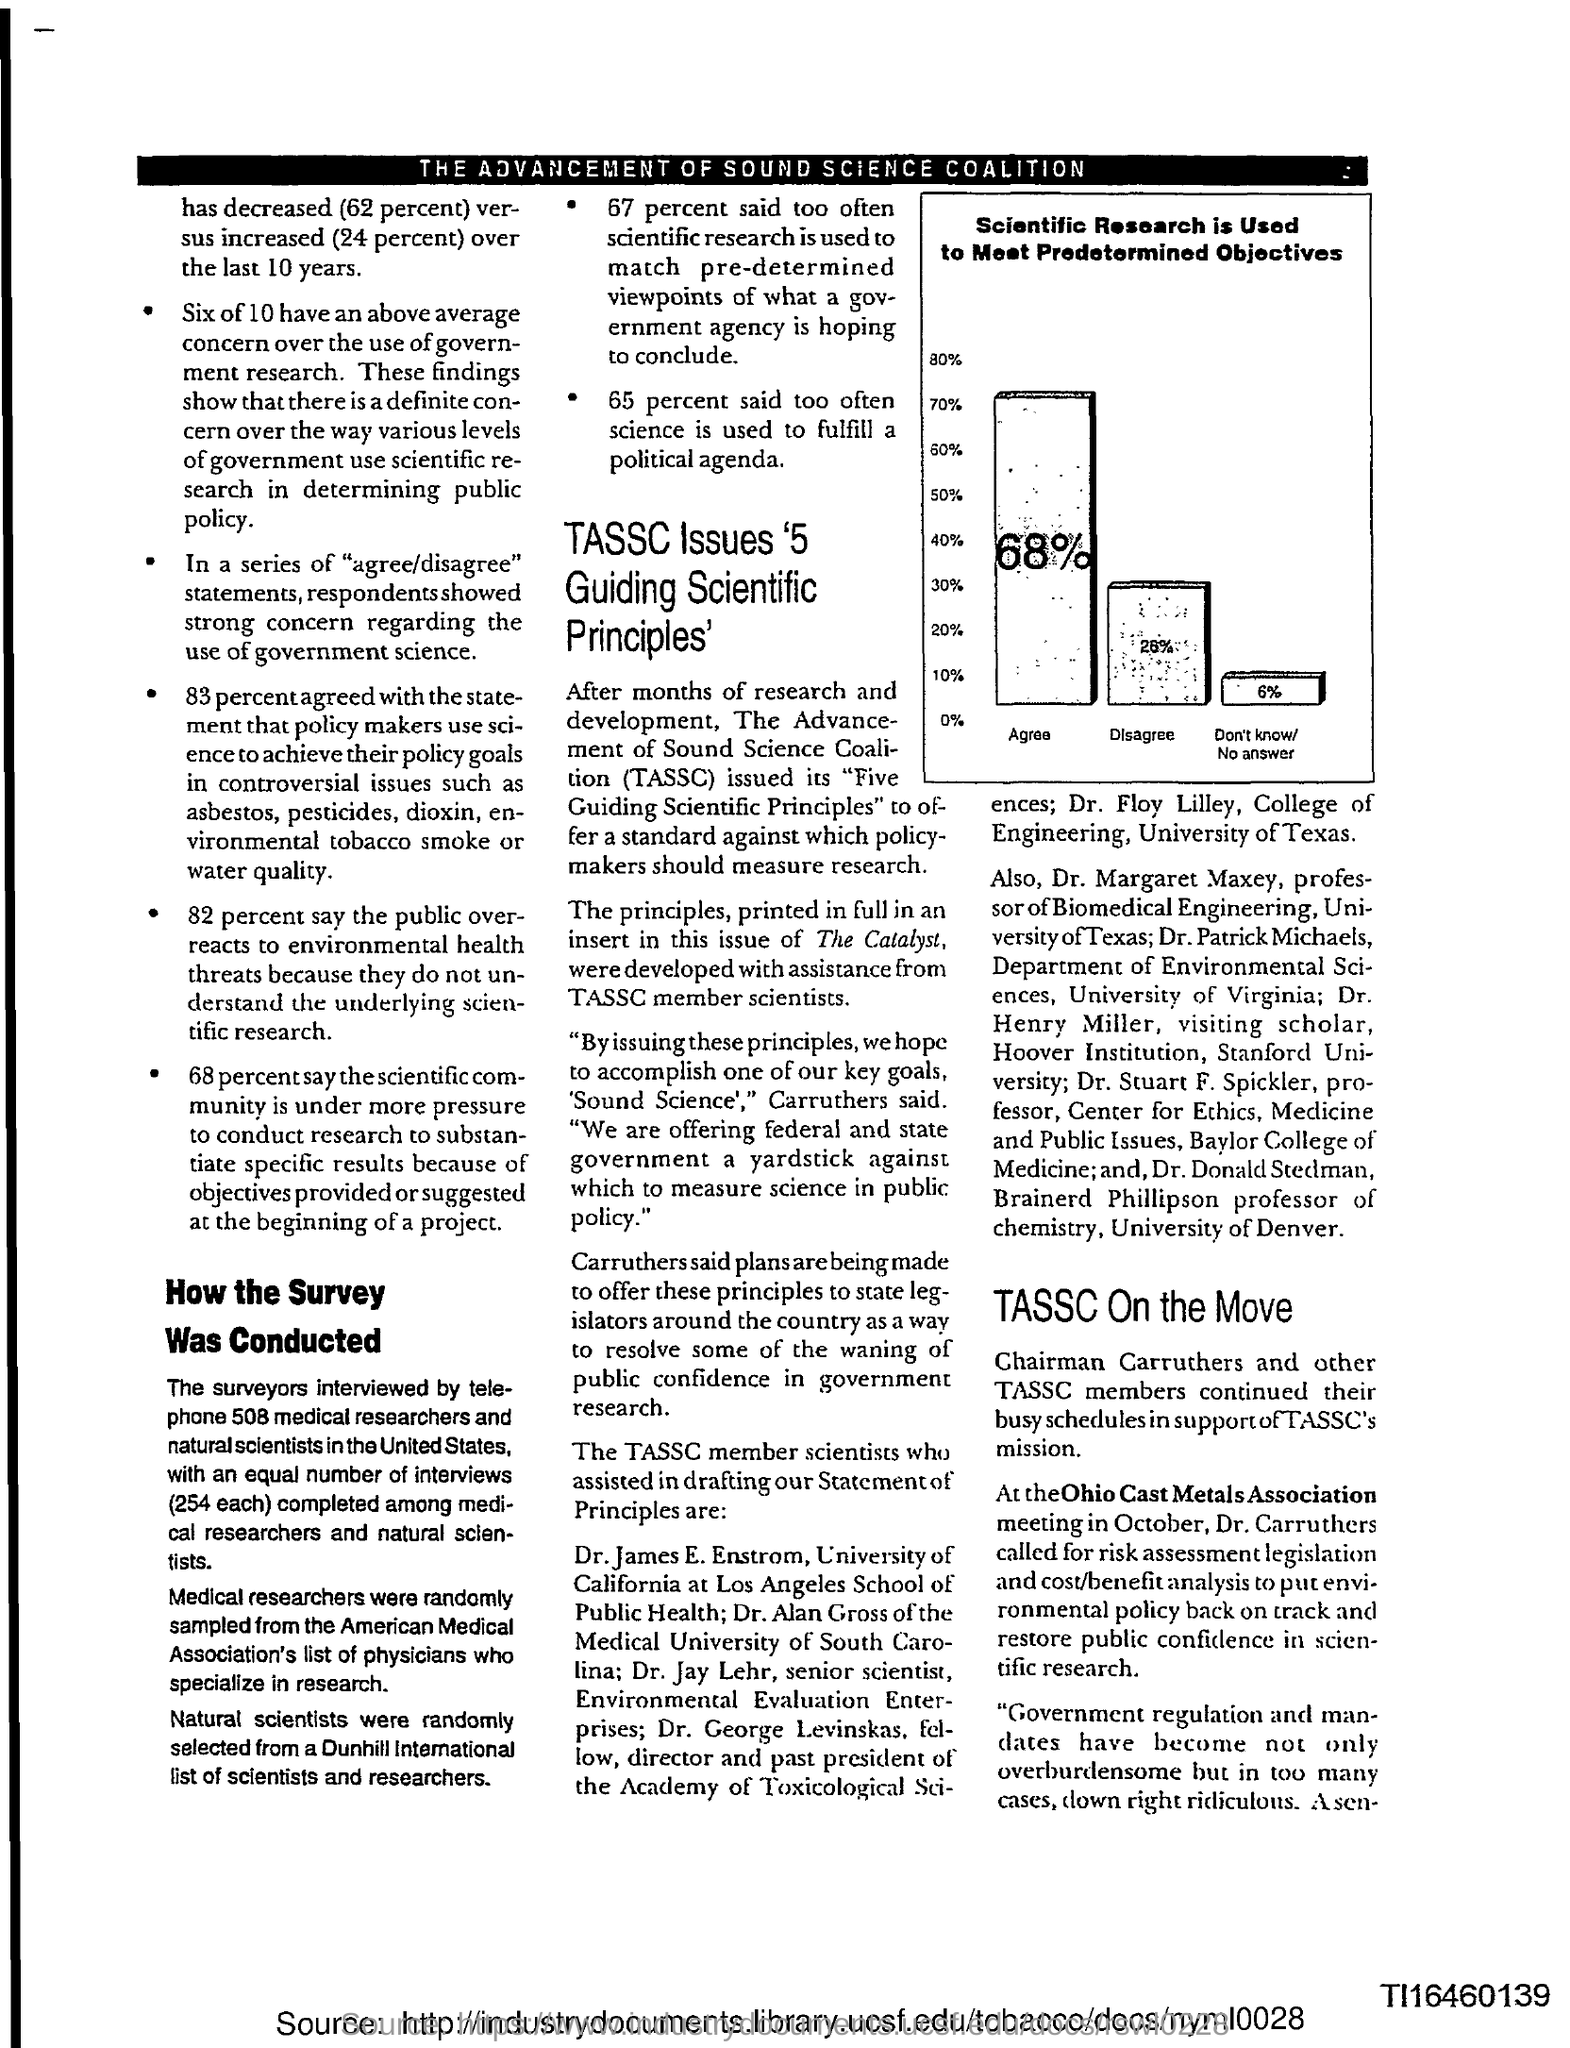Identify some key points in this picture. The Chairman of TASSC is Carruthers. According to the survey, 65% of those surveyed believe that science is often used to fulfill a political agenda. Dr. Carruthers called for risk assessment legislation at the Ohio Cast Metals Association meeting in October. The acronym "TASSC" stands for "The Advancement of Sound Science Coalition. 